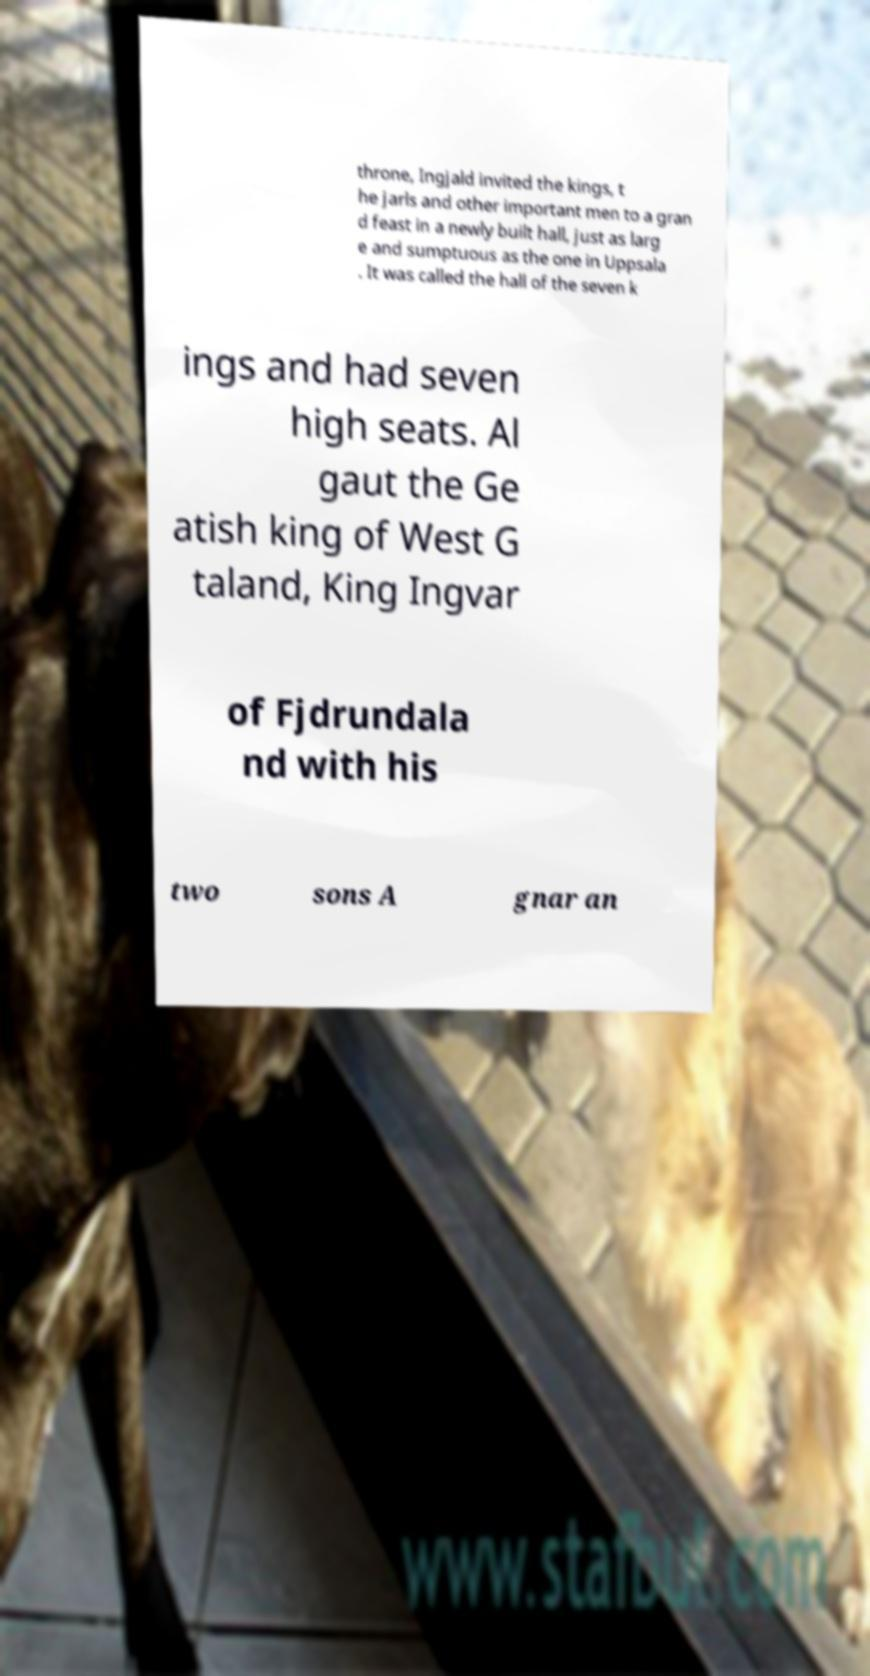Can you read and provide the text displayed in the image?This photo seems to have some interesting text. Can you extract and type it out for me? throne, Ingjald invited the kings, t he jarls and other important men to a gran d feast in a newly built hall, just as larg e and sumptuous as the one in Uppsala . It was called the hall of the seven k ings and had seven high seats. Al gaut the Ge atish king of West G taland, King Ingvar of Fjdrundala nd with his two sons A gnar an 